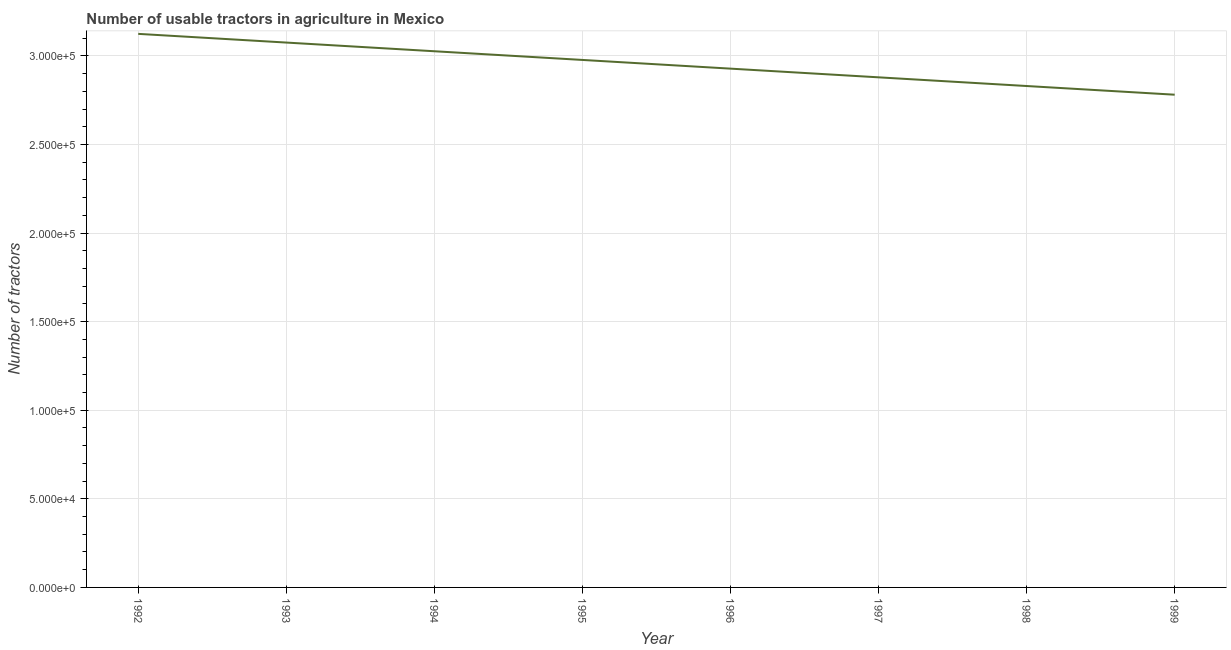What is the number of tractors in 1995?
Offer a very short reply. 2.98e+05. Across all years, what is the maximum number of tractors?
Keep it short and to the point. 3.12e+05. Across all years, what is the minimum number of tractors?
Provide a short and direct response. 2.78e+05. In which year was the number of tractors maximum?
Provide a succinct answer. 1992. What is the sum of the number of tractors?
Give a very brief answer. 2.36e+06. What is the difference between the number of tractors in 1996 and 1998?
Your answer should be compact. 9810. What is the average number of tractors per year?
Keep it short and to the point. 2.95e+05. What is the median number of tractors?
Provide a short and direct response. 2.95e+05. In how many years, is the number of tractors greater than 300000 ?
Ensure brevity in your answer.  3. What is the ratio of the number of tractors in 1995 to that in 1996?
Your response must be concise. 1.02. Is the number of tractors in 1994 less than that in 1995?
Give a very brief answer. No. Is the difference between the number of tractors in 1995 and 1996 greater than the difference between any two years?
Offer a terse response. No. What is the difference between the highest and the second highest number of tractors?
Ensure brevity in your answer.  4905. What is the difference between the highest and the lowest number of tractors?
Offer a terse response. 3.43e+04. Does the number of tractors monotonically increase over the years?
Your answer should be compact. No. What is the difference between two consecutive major ticks on the Y-axis?
Your response must be concise. 5.00e+04. Does the graph contain any zero values?
Give a very brief answer. No. What is the title of the graph?
Your response must be concise. Number of usable tractors in agriculture in Mexico. What is the label or title of the Y-axis?
Your response must be concise. Number of tractors. What is the Number of tractors of 1992?
Your answer should be compact. 3.12e+05. What is the Number of tractors of 1993?
Keep it short and to the point. 3.08e+05. What is the Number of tractors of 1994?
Ensure brevity in your answer.  3.03e+05. What is the Number of tractors in 1995?
Your answer should be very brief. 2.98e+05. What is the Number of tractors in 1996?
Offer a terse response. 2.93e+05. What is the Number of tractors in 1997?
Your answer should be compact. 2.88e+05. What is the Number of tractors in 1998?
Your answer should be compact. 2.83e+05. What is the Number of tractors of 1999?
Ensure brevity in your answer.  2.78e+05. What is the difference between the Number of tractors in 1992 and 1993?
Ensure brevity in your answer.  4905. What is the difference between the Number of tractors in 1992 and 1994?
Make the answer very short. 9811. What is the difference between the Number of tractors in 1992 and 1995?
Your response must be concise. 1.47e+04. What is the difference between the Number of tractors in 1992 and 1996?
Your answer should be compact. 1.96e+04. What is the difference between the Number of tractors in 1992 and 1997?
Offer a very short reply. 2.45e+04. What is the difference between the Number of tractors in 1992 and 1998?
Provide a short and direct response. 2.94e+04. What is the difference between the Number of tractors in 1992 and 1999?
Ensure brevity in your answer.  3.43e+04. What is the difference between the Number of tractors in 1993 and 1994?
Ensure brevity in your answer.  4906. What is the difference between the Number of tractors in 1993 and 1995?
Make the answer very short. 9811. What is the difference between the Number of tractors in 1993 and 1996?
Offer a very short reply. 1.47e+04. What is the difference between the Number of tractors in 1993 and 1997?
Give a very brief answer. 1.96e+04. What is the difference between the Number of tractors in 1993 and 1998?
Your answer should be compact. 2.45e+04. What is the difference between the Number of tractors in 1993 and 1999?
Provide a short and direct response. 2.94e+04. What is the difference between the Number of tractors in 1994 and 1995?
Give a very brief answer. 4905. What is the difference between the Number of tractors in 1994 and 1996?
Offer a very short reply. 9810. What is the difference between the Number of tractors in 1994 and 1997?
Your answer should be very brief. 1.47e+04. What is the difference between the Number of tractors in 1994 and 1998?
Make the answer very short. 1.96e+04. What is the difference between the Number of tractors in 1994 and 1999?
Offer a terse response. 2.45e+04. What is the difference between the Number of tractors in 1995 and 1996?
Your answer should be compact. 4905. What is the difference between the Number of tractors in 1995 and 1997?
Your answer should be very brief. 9810. What is the difference between the Number of tractors in 1995 and 1998?
Your answer should be very brief. 1.47e+04. What is the difference between the Number of tractors in 1995 and 1999?
Your answer should be very brief. 1.96e+04. What is the difference between the Number of tractors in 1996 and 1997?
Make the answer very short. 4905. What is the difference between the Number of tractors in 1996 and 1998?
Offer a very short reply. 9810. What is the difference between the Number of tractors in 1996 and 1999?
Provide a short and direct response. 1.47e+04. What is the difference between the Number of tractors in 1997 and 1998?
Your response must be concise. 4905. What is the difference between the Number of tractors in 1997 and 1999?
Offer a very short reply. 9810. What is the difference between the Number of tractors in 1998 and 1999?
Offer a terse response. 4905. What is the ratio of the Number of tractors in 1992 to that in 1994?
Keep it short and to the point. 1.03. What is the ratio of the Number of tractors in 1992 to that in 1995?
Offer a very short reply. 1.05. What is the ratio of the Number of tractors in 1992 to that in 1996?
Ensure brevity in your answer.  1.07. What is the ratio of the Number of tractors in 1992 to that in 1997?
Your answer should be very brief. 1.08. What is the ratio of the Number of tractors in 1992 to that in 1998?
Your answer should be very brief. 1.1. What is the ratio of the Number of tractors in 1992 to that in 1999?
Provide a short and direct response. 1.12. What is the ratio of the Number of tractors in 1993 to that in 1994?
Your response must be concise. 1.02. What is the ratio of the Number of tractors in 1993 to that in 1995?
Your response must be concise. 1.03. What is the ratio of the Number of tractors in 1993 to that in 1996?
Make the answer very short. 1.05. What is the ratio of the Number of tractors in 1993 to that in 1997?
Make the answer very short. 1.07. What is the ratio of the Number of tractors in 1993 to that in 1998?
Your response must be concise. 1.09. What is the ratio of the Number of tractors in 1993 to that in 1999?
Ensure brevity in your answer.  1.11. What is the ratio of the Number of tractors in 1994 to that in 1995?
Offer a very short reply. 1.02. What is the ratio of the Number of tractors in 1994 to that in 1996?
Provide a short and direct response. 1.03. What is the ratio of the Number of tractors in 1994 to that in 1997?
Keep it short and to the point. 1.05. What is the ratio of the Number of tractors in 1994 to that in 1998?
Your answer should be very brief. 1.07. What is the ratio of the Number of tractors in 1994 to that in 1999?
Provide a short and direct response. 1.09. What is the ratio of the Number of tractors in 1995 to that in 1997?
Give a very brief answer. 1.03. What is the ratio of the Number of tractors in 1995 to that in 1998?
Your answer should be very brief. 1.05. What is the ratio of the Number of tractors in 1995 to that in 1999?
Give a very brief answer. 1.07. What is the ratio of the Number of tractors in 1996 to that in 1998?
Provide a succinct answer. 1.03. What is the ratio of the Number of tractors in 1996 to that in 1999?
Give a very brief answer. 1.05. What is the ratio of the Number of tractors in 1997 to that in 1998?
Your answer should be compact. 1.02. What is the ratio of the Number of tractors in 1997 to that in 1999?
Your answer should be very brief. 1.03. 